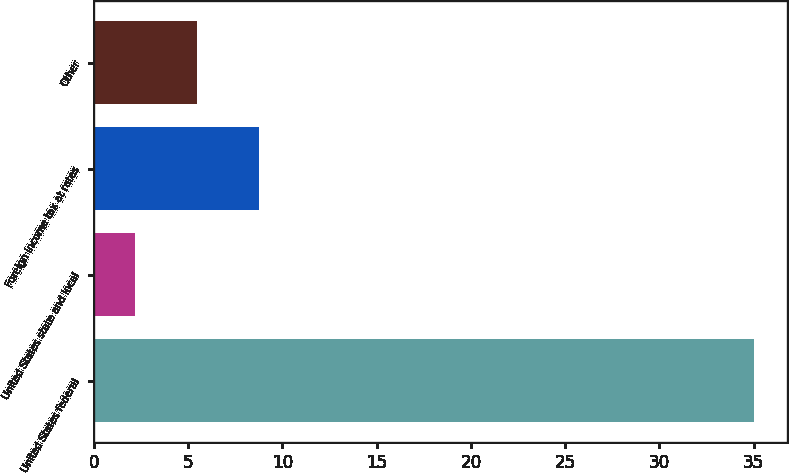<chart> <loc_0><loc_0><loc_500><loc_500><bar_chart><fcel>United States federal<fcel>United States state and local<fcel>Foreign income tax at rates<fcel>Other<nl><fcel>35<fcel>2.2<fcel>8.76<fcel>5.48<nl></chart> 